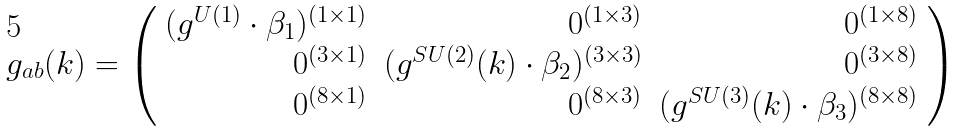Convert formula to latex. <formula><loc_0><loc_0><loc_500><loc_500>g _ { a b } ( k ) = \left ( \begin{array} { r r r } { { ( g ^ { U ( 1 ) } \cdot \beta _ { 1 } ) ^ { ( 1 \times 1 ) } } } & { { 0 ^ { ( 1 \times 3 ) } } } & { { 0 ^ { ( 1 \times 8 ) } } } \\ { { 0 ^ { ( 3 \times 1 ) } } } & { { ( g ^ { S U ( 2 ) } ( k ) \cdot \beta _ { 2 } ) ^ { ( 3 \times 3 ) } } } & { { 0 ^ { ( 3 \times 8 ) } } } \\ { { 0 ^ { ( 8 \times 1 ) } } } & { { 0 ^ { ( 8 \times 3 ) } } } & { { ( g ^ { S U ( 3 ) } ( k ) \cdot \beta _ { 3 } ) ^ { ( 8 \times 8 ) } } } \end{array} \right )</formula> 